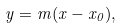<formula> <loc_0><loc_0><loc_500><loc_500>y = m ( x - x _ { 0 } ) ,</formula> 